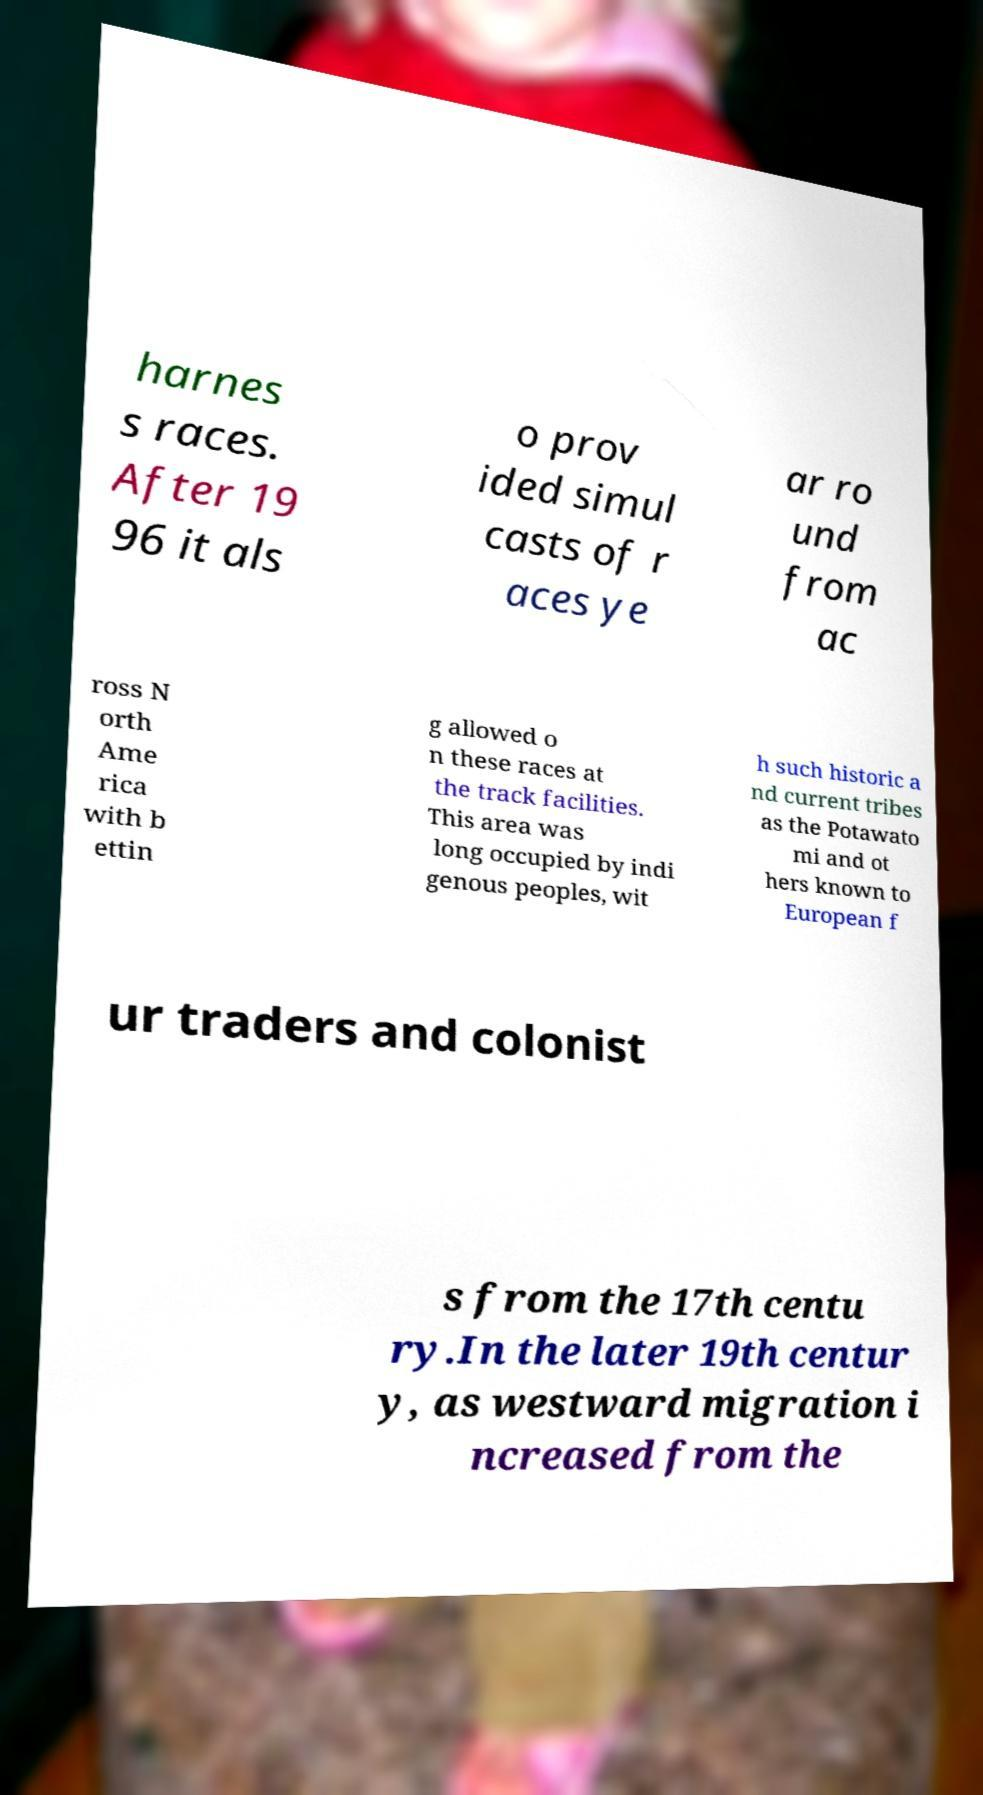Could you extract and type out the text from this image? harnes s races. After 19 96 it als o prov ided simul casts of r aces ye ar ro und from ac ross N orth Ame rica with b ettin g allowed o n these races at the track facilities. This area was long occupied by indi genous peoples, wit h such historic a nd current tribes as the Potawato mi and ot hers known to European f ur traders and colonist s from the 17th centu ry.In the later 19th centur y, as westward migration i ncreased from the 